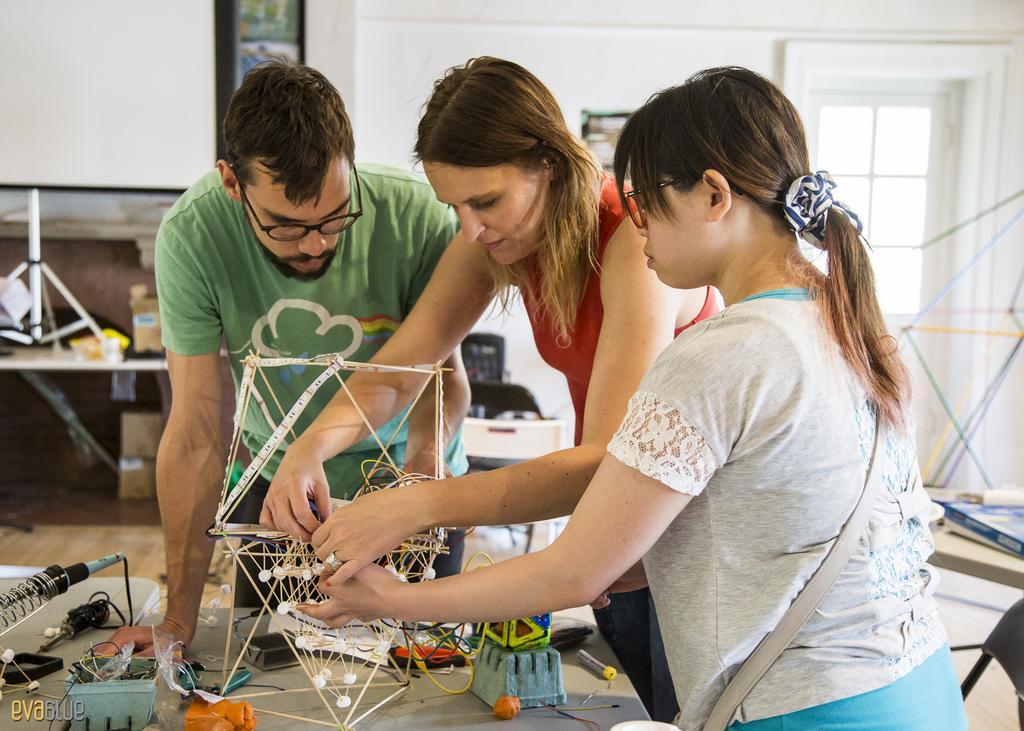Can you describe this image briefly? In this image we can see a few people holding an object, in front of them, we can see some objects on the table, also we can see there are some other objects in the room, in the background we can see a window and the wall with a photo frame. 